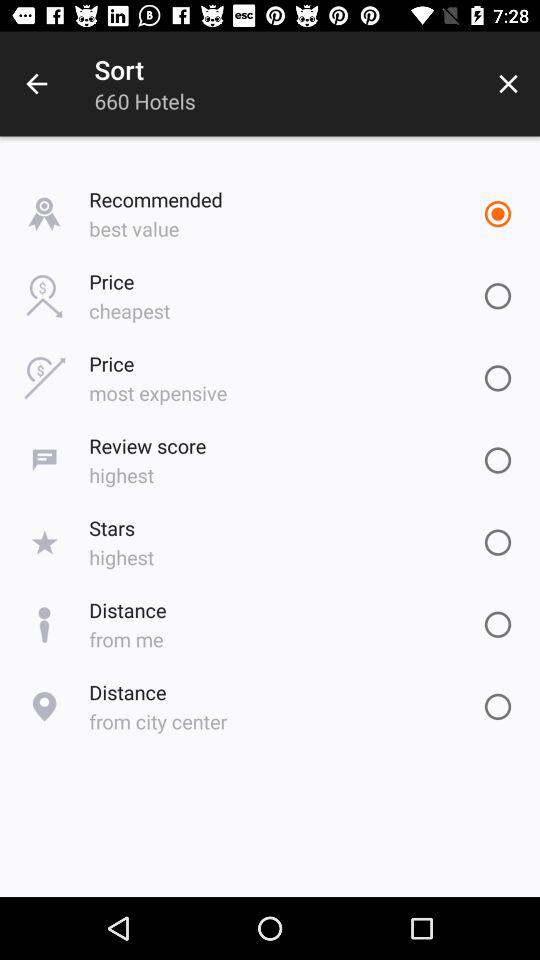Which option is currently selected? The currently selected option is "Recommended". 